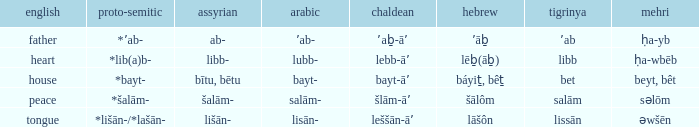When the word is "heart" in english, what is its hebrew equivalent? Lēḇ(āḇ). 